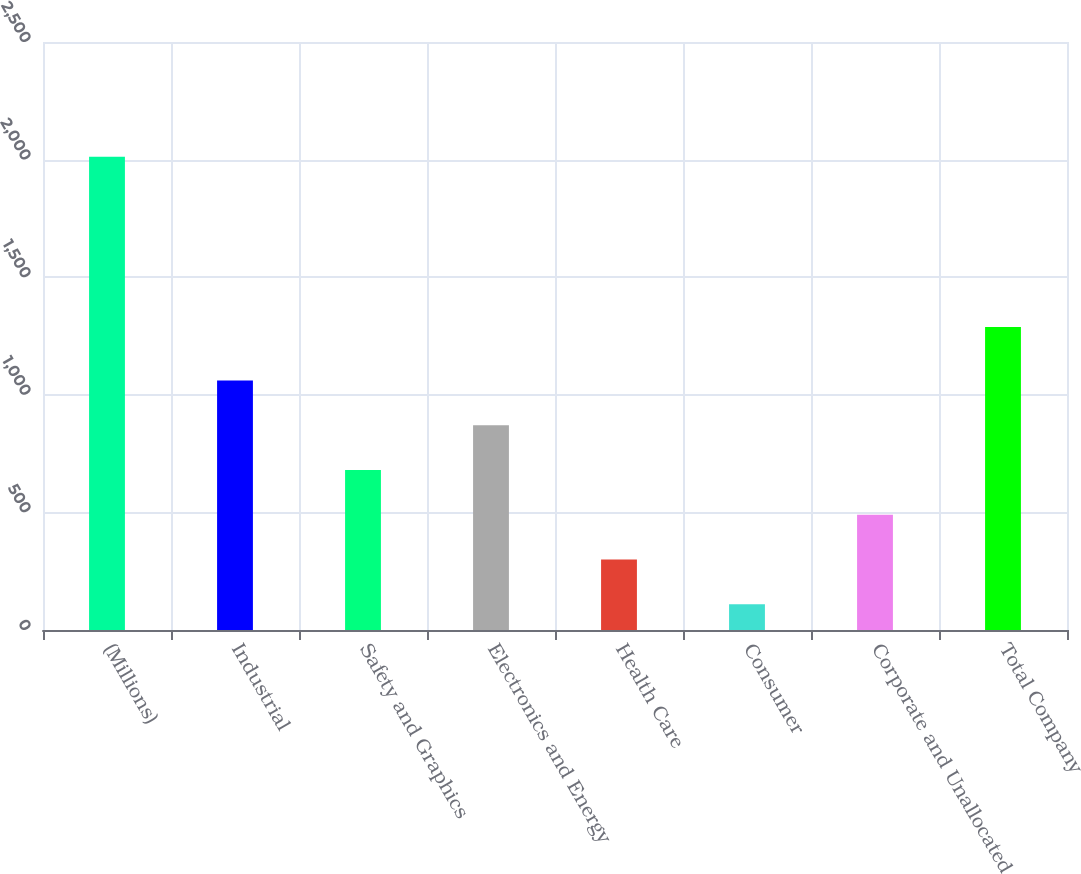Convert chart to OTSL. <chart><loc_0><loc_0><loc_500><loc_500><bar_chart><fcel>(Millions)<fcel>Industrial<fcel>Safety and Graphics<fcel>Electronics and Energy<fcel>Health Care<fcel>Consumer<fcel>Corporate and Unallocated<fcel>Total Company<nl><fcel>2012<fcel>1061<fcel>680.6<fcel>870.8<fcel>300.2<fcel>110<fcel>490.4<fcel>1288<nl></chart> 